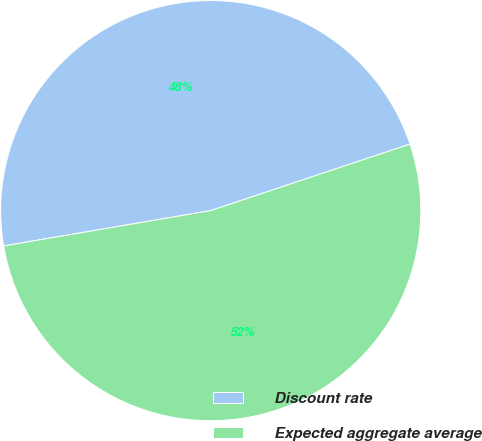Convert chart to OTSL. <chart><loc_0><loc_0><loc_500><loc_500><pie_chart><fcel>Discount rate<fcel>Expected aggregate average<nl><fcel>47.56%<fcel>52.44%<nl></chart> 